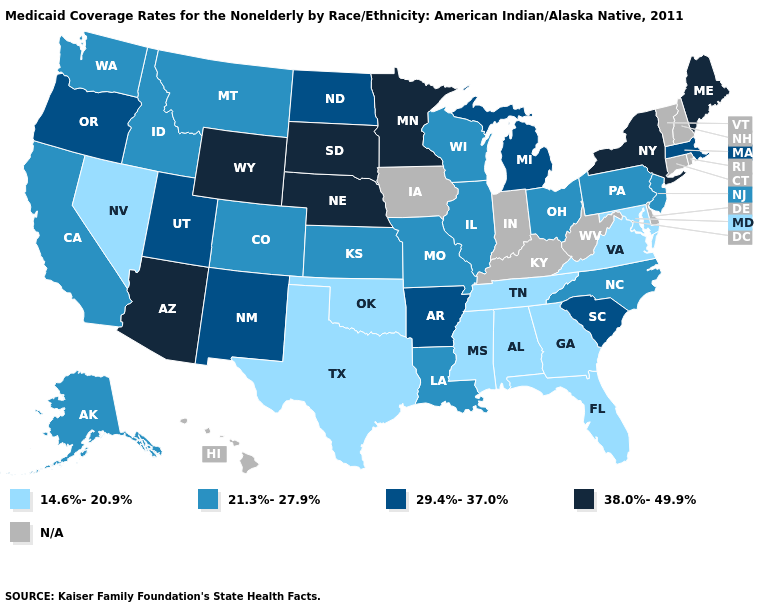What is the highest value in states that border Utah?
Write a very short answer. 38.0%-49.9%. What is the value of Oregon?
Short answer required. 29.4%-37.0%. What is the lowest value in the West?
Keep it brief. 14.6%-20.9%. Among the states that border Delaware , does Maryland have the highest value?
Short answer required. No. Name the states that have a value in the range 29.4%-37.0%?
Be succinct. Arkansas, Massachusetts, Michigan, New Mexico, North Dakota, Oregon, South Carolina, Utah. Name the states that have a value in the range 38.0%-49.9%?
Quick response, please. Arizona, Maine, Minnesota, Nebraska, New York, South Dakota, Wyoming. Does Nevada have the lowest value in the West?
Give a very brief answer. Yes. Does the map have missing data?
Quick response, please. Yes. Does Minnesota have the highest value in the USA?
Answer briefly. Yes. What is the value of Florida?
Concise answer only. 14.6%-20.9%. What is the lowest value in the South?
Write a very short answer. 14.6%-20.9%. Which states have the lowest value in the USA?
Short answer required. Alabama, Florida, Georgia, Maryland, Mississippi, Nevada, Oklahoma, Tennessee, Texas, Virginia. Does New Jersey have the lowest value in the Northeast?
Concise answer only. Yes. Name the states that have a value in the range 21.3%-27.9%?
Be succinct. Alaska, California, Colorado, Idaho, Illinois, Kansas, Louisiana, Missouri, Montana, New Jersey, North Carolina, Ohio, Pennsylvania, Washington, Wisconsin. 